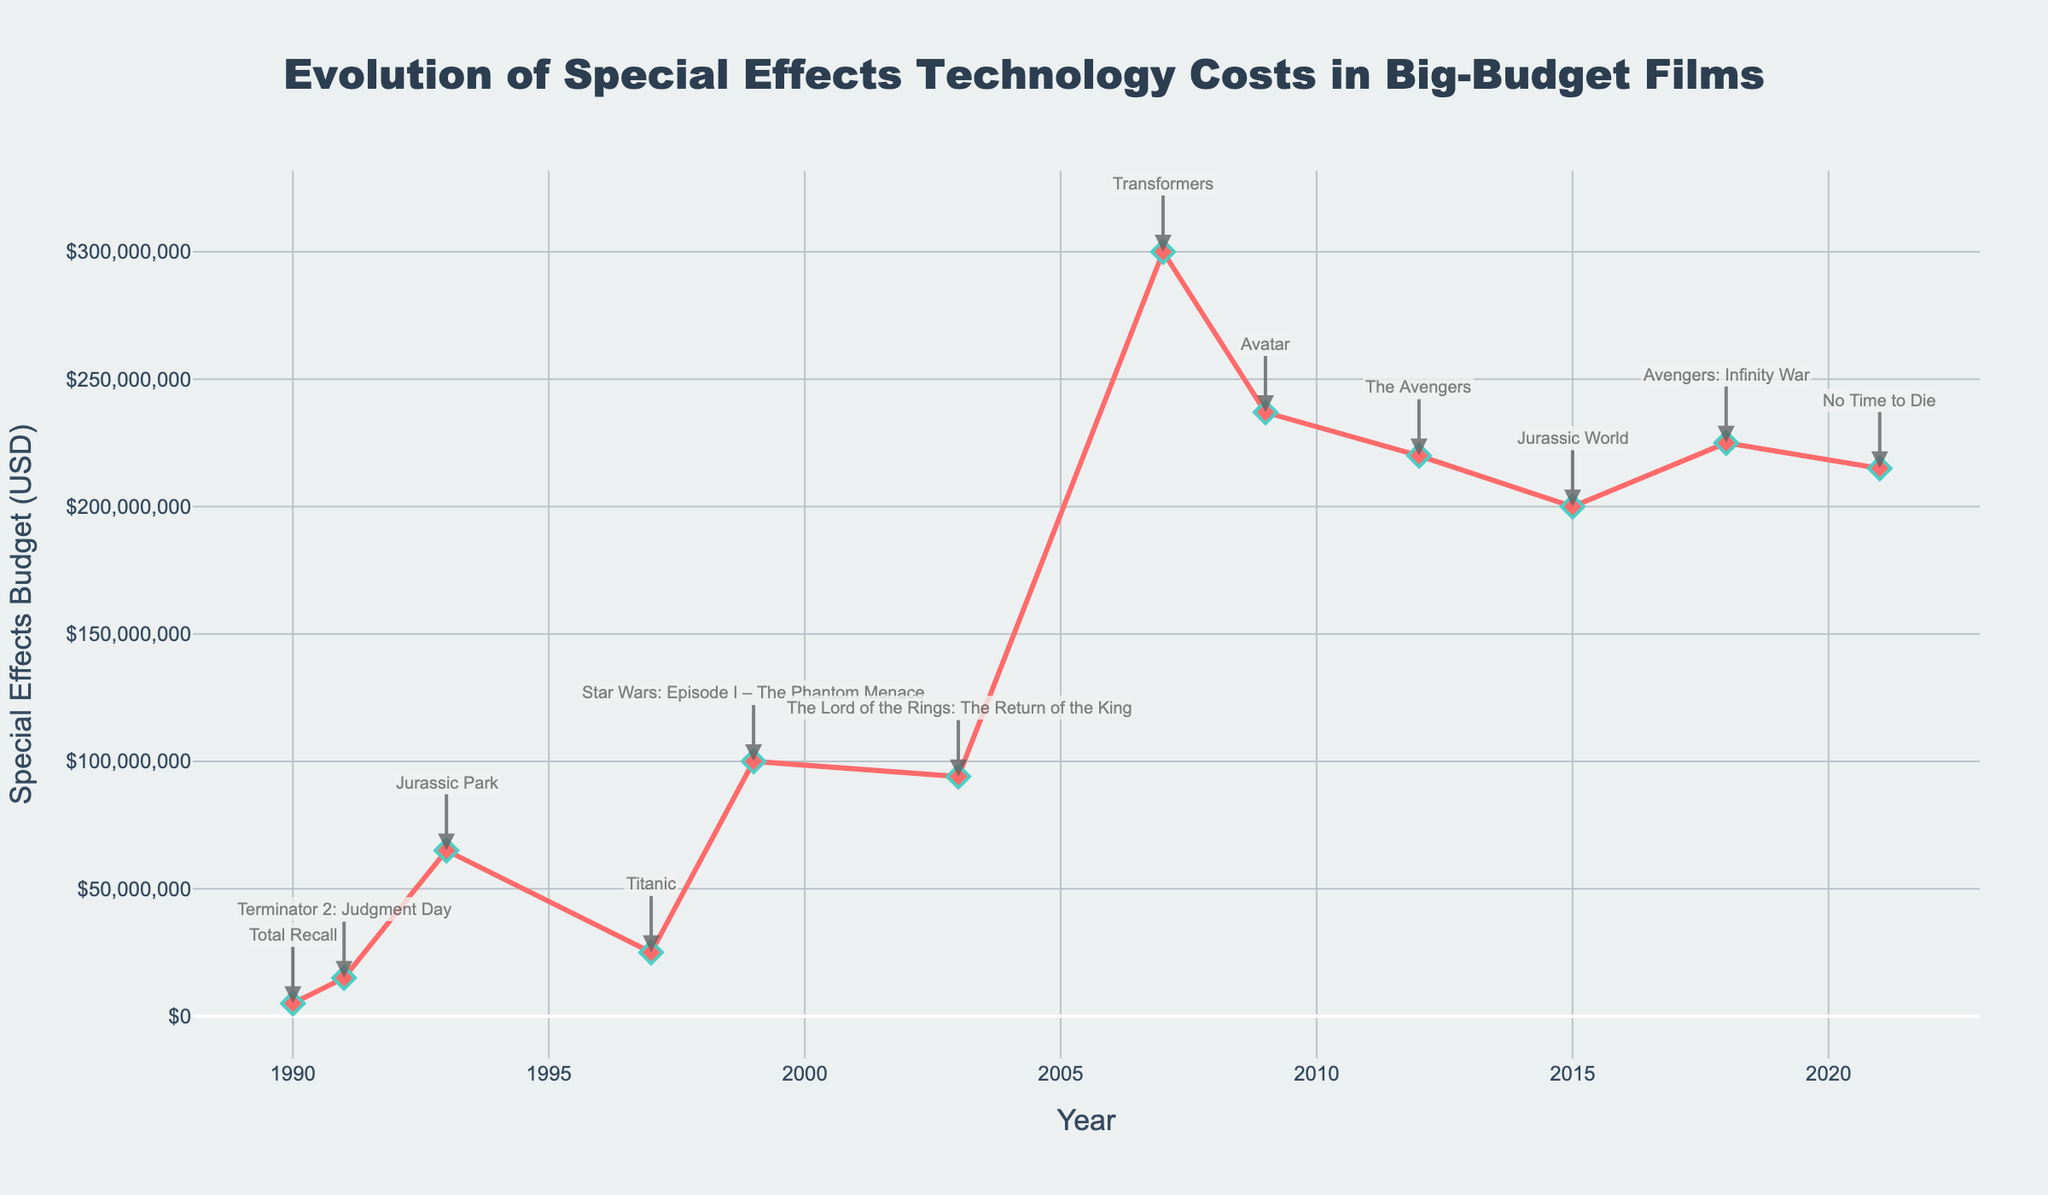What's the title of the plot? The title of the plot is shown at the top of the figure. It reads “Evolution of Special Effects Technology Costs in Big-Budget Films”.
Answer: Evolution of Special Effects Technology Costs in Big-Budget Films What is the y-axis label in the plot? The y-axis label displays the unit of measurement for the vertical axis. It is labeled as "Special Effects Budget (USD)".
Answer: Special Effects Budget (USD) How many data points are there in the plot? Each mark on the plot represents a data point for a specific year and movie. By counting these marks, there are 12 data points shown.
Answer: 12 What was the Special Effects Budget for "Avatar" in 2009? Locate the point corresponding to the year 2009 and check its label. It indicates the movie "Avatar" with a budget value of $237,000,000.
Answer: $237,000,000 Which year had the lowest special effects budget, and what was the budget amount? Look for the data point with the minimum y-value and check its label to find the year and budget amount. In 1990, "Total Recall" had the lowest budget of $5,000,000.
Answer: 1990, $5,000,000 How did the Special Effects Budget change from "Jurassic Park" in 1993 to "Transformers" in 2007? Identify the budget values for both movies: "Jurassic Park" in 1993 with $65,000,000 and "Transformers" in 2007 with $300,000,000. Calculate the difference: $300,000,000 - $65,000,000 = $235,000,000.
Answer: Increased by $235,000,000 Which movie had the highest Special Effects Budget and what was the amount? Find the highest point on the y-axis and check its annotation for the movie title and budget amount. "Transformers" in 2007 had the highest budget of $300,000,000.
Answer: Transformers, $300,000,000 What's the average Special Effects Budget for the movies displayed on the plot? Add up all the Special Effects Budgets and divide by the number of movies. The total sum is $2,002,000,000. Divided by 12: $2,002,000,000 / 12 ≈ $166,833,333.33.
Answer: $166,833,333.33 Between 2015 and 2021, did the Special Effects Budget generally increase or decrease? Compare the budgets in 2015 ("Jurassic World" $200,000,000) and 2021 ("No Time to Die" $215,000,000). The budget increased by $15,000,000 over this period.
Answer: Increased What trend can you observe in the Special Effects Budget from 1990 to 2021? Observing the overall direction of the plot line from the start year to the end year: The Special Effects Budget shows a general increasing trend over time, with some fluctuations.
Answer: General increase with fluctuations 